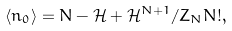<formula> <loc_0><loc_0><loc_500><loc_500>\langle n _ { 0 } \rangle = N - \mathcal { H } + \mathcal { H } ^ { N + 1 } / Z _ { N } N ! ,</formula> 